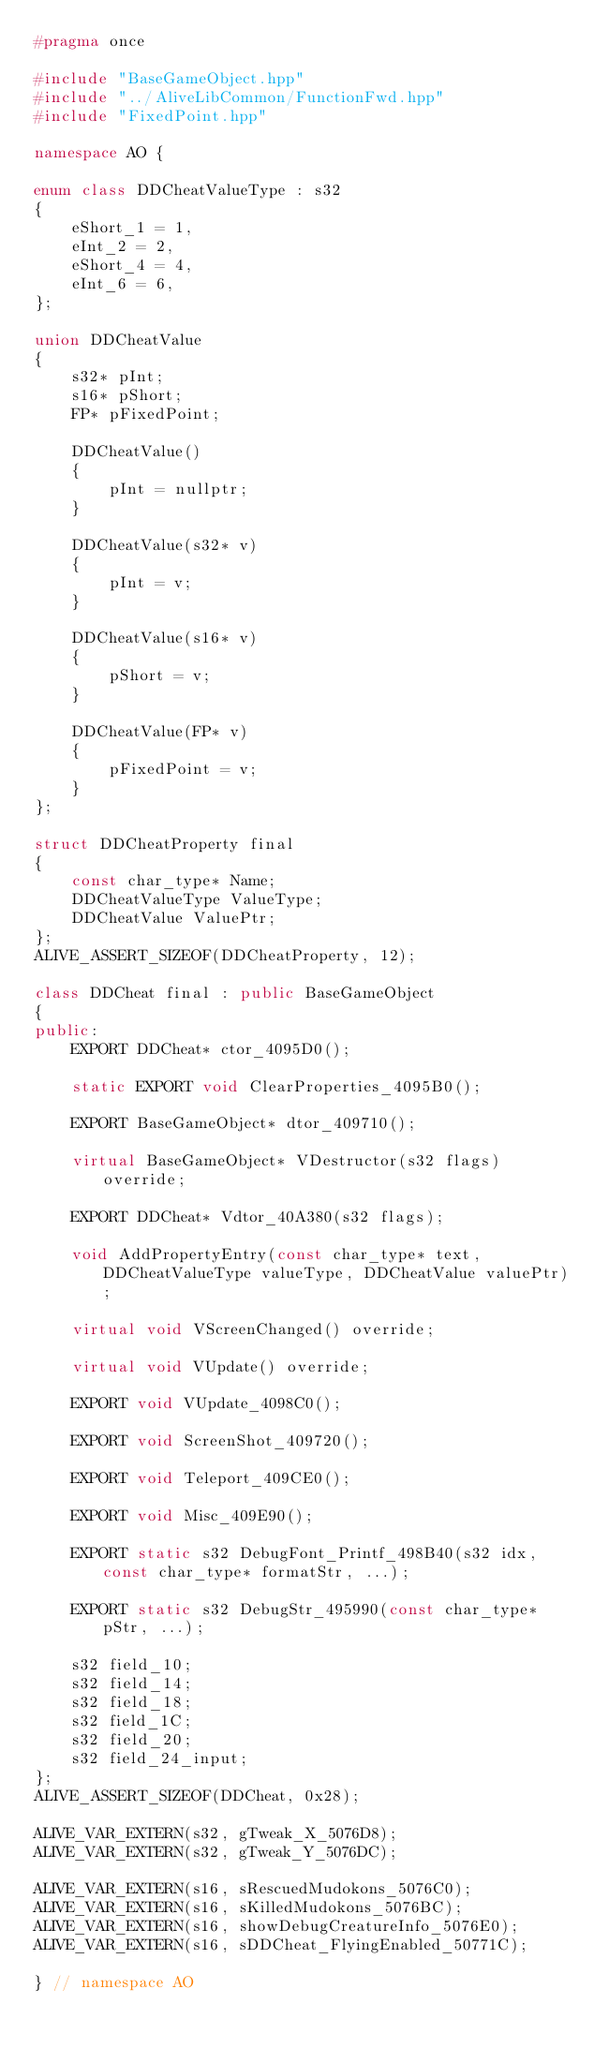Convert code to text. <code><loc_0><loc_0><loc_500><loc_500><_C++_>#pragma once

#include "BaseGameObject.hpp"
#include "../AliveLibCommon/FunctionFwd.hpp"
#include "FixedPoint.hpp"

namespace AO {

enum class DDCheatValueType : s32
{
    eShort_1 = 1,
    eInt_2 = 2,
    eShort_4 = 4,
    eInt_6 = 6,
};

union DDCheatValue
{
    s32* pInt;
    s16* pShort;
    FP* pFixedPoint;

    DDCheatValue()
    {
        pInt = nullptr;
    }

    DDCheatValue(s32* v)
    {
        pInt = v;
    }

    DDCheatValue(s16* v)
    {
        pShort = v;
    }

    DDCheatValue(FP* v)
    {
        pFixedPoint = v;
    }
};

struct DDCheatProperty final
{
    const char_type* Name;
    DDCheatValueType ValueType;
    DDCheatValue ValuePtr;
};
ALIVE_ASSERT_SIZEOF(DDCheatProperty, 12);

class DDCheat final : public BaseGameObject
{
public:
    EXPORT DDCheat* ctor_4095D0();

    static EXPORT void ClearProperties_4095B0();

    EXPORT BaseGameObject* dtor_409710();

    virtual BaseGameObject* VDestructor(s32 flags) override;

    EXPORT DDCheat* Vdtor_40A380(s32 flags);

    void AddPropertyEntry(const char_type* text, DDCheatValueType valueType, DDCheatValue valuePtr);

    virtual void VScreenChanged() override;

    virtual void VUpdate() override;

    EXPORT void VUpdate_4098C0();

    EXPORT void ScreenShot_409720();

    EXPORT void Teleport_409CE0();

    EXPORT void Misc_409E90();

    EXPORT static s32 DebugFont_Printf_498B40(s32 idx, const char_type* formatStr, ...);

    EXPORT static s32 DebugStr_495990(const char_type* pStr, ...);

    s32 field_10;
    s32 field_14;
    s32 field_18;
    s32 field_1C;
    s32 field_20;
    s32 field_24_input;
};
ALIVE_ASSERT_SIZEOF(DDCheat, 0x28);

ALIVE_VAR_EXTERN(s32, gTweak_X_5076D8);
ALIVE_VAR_EXTERN(s32, gTweak_Y_5076DC);

ALIVE_VAR_EXTERN(s16, sRescuedMudokons_5076C0);
ALIVE_VAR_EXTERN(s16, sKilledMudokons_5076BC);
ALIVE_VAR_EXTERN(s16, showDebugCreatureInfo_5076E0);
ALIVE_VAR_EXTERN(s16, sDDCheat_FlyingEnabled_50771C);

} // namespace AO
</code> 